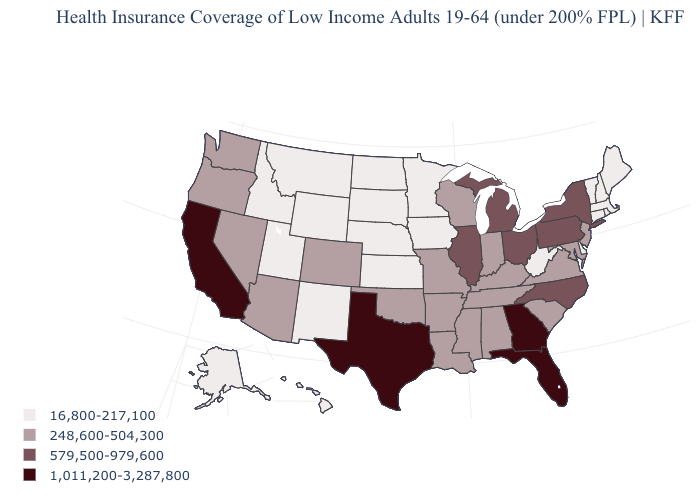Does Maine have a lower value than Kansas?
Concise answer only. No. Does New Mexico have the same value as Oregon?
Short answer required. No. What is the lowest value in the USA?
Write a very short answer. 16,800-217,100. Which states have the highest value in the USA?
Concise answer only. California, Florida, Georgia, Texas. What is the value of Washington?
Keep it brief. 248,600-504,300. What is the value of Idaho?
Answer briefly. 16,800-217,100. What is the highest value in the MidWest ?
Quick response, please. 579,500-979,600. Name the states that have a value in the range 16,800-217,100?
Be succinct. Alaska, Connecticut, Delaware, Hawaii, Idaho, Iowa, Kansas, Maine, Massachusetts, Minnesota, Montana, Nebraska, New Hampshire, New Mexico, North Dakota, Rhode Island, South Dakota, Utah, Vermont, West Virginia, Wyoming. Is the legend a continuous bar?
Concise answer only. No. What is the lowest value in the USA?
Keep it brief. 16,800-217,100. Name the states that have a value in the range 248,600-504,300?
Quick response, please. Alabama, Arizona, Arkansas, Colorado, Indiana, Kentucky, Louisiana, Maryland, Mississippi, Missouri, Nevada, New Jersey, Oklahoma, Oregon, South Carolina, Tennessee, Virginia, Washington, Wisconsin. Does Maine have the lowest value in the USA?
Short answer required. Yes. Does Rhode Island have the same value as Ohio?
Quick response, please. No. What is the value of Kansas?
Give a very brief answer. 16,800-217,100. 